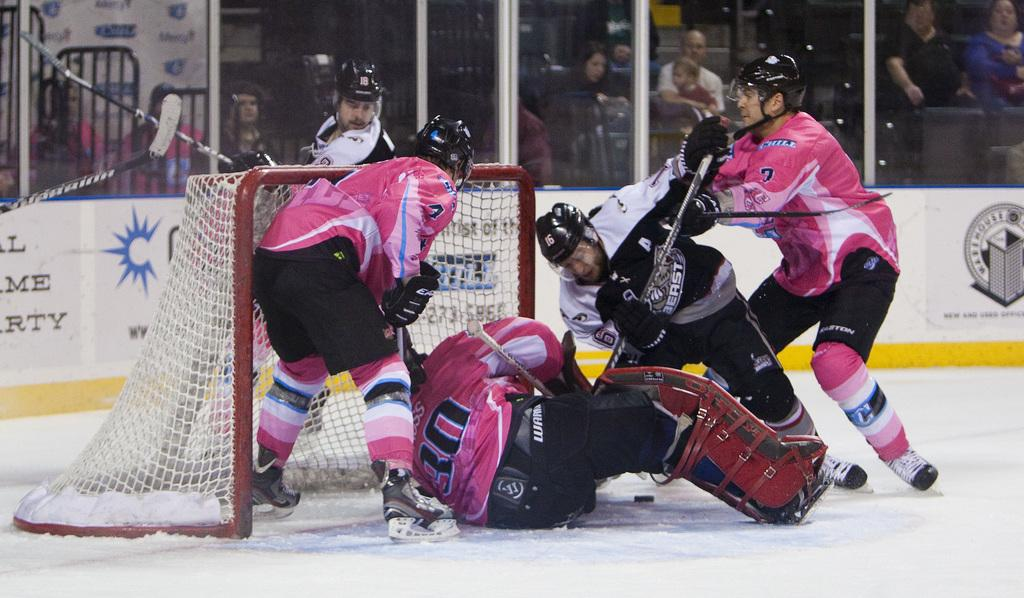Provide a one-sentence caption for the provided image. The goalie in the pink uniform is wearing the number 30. 